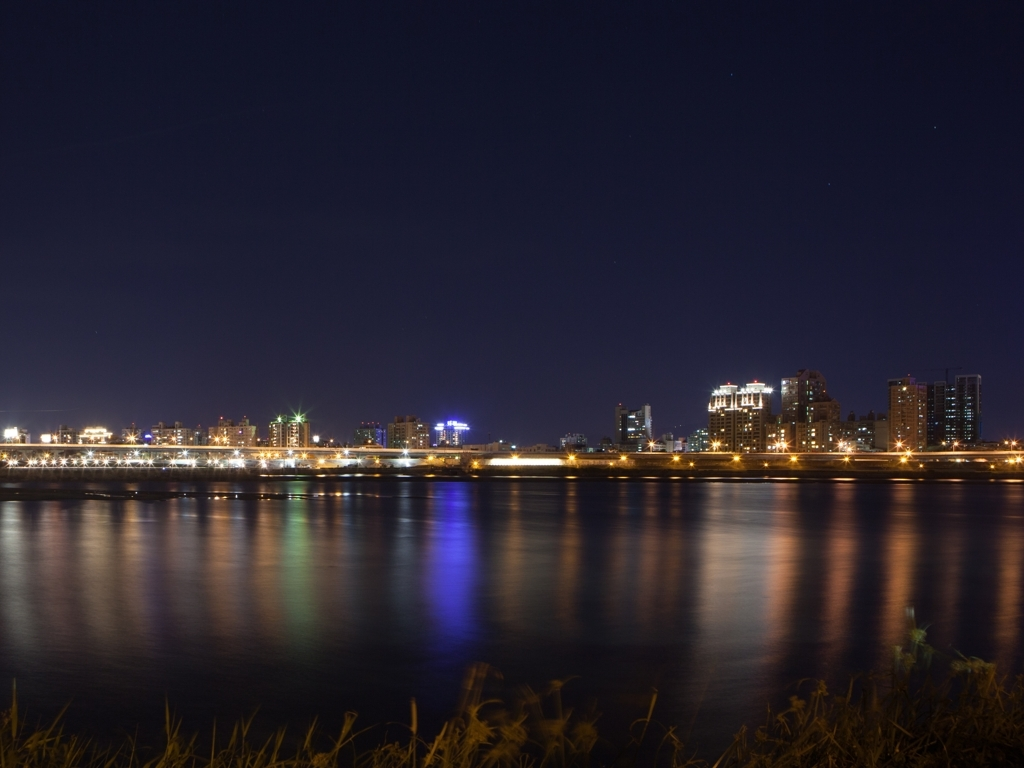Can you describe the likely location where this photo was taken? This photo was likely taken from a vantage point across a body of water, such as a riverbank or lakeside, providing a clear and unobstructed view of the city skyline. What type of camera settings might have been used to capture this image? To capture the clarity and stillness of the city lights and their reflection, a camera with a long exposure setting would have been used. Additionally, a low ISO to reduce noise and a small aperture would help to get everything in focus, from the foreground to the skyline. 